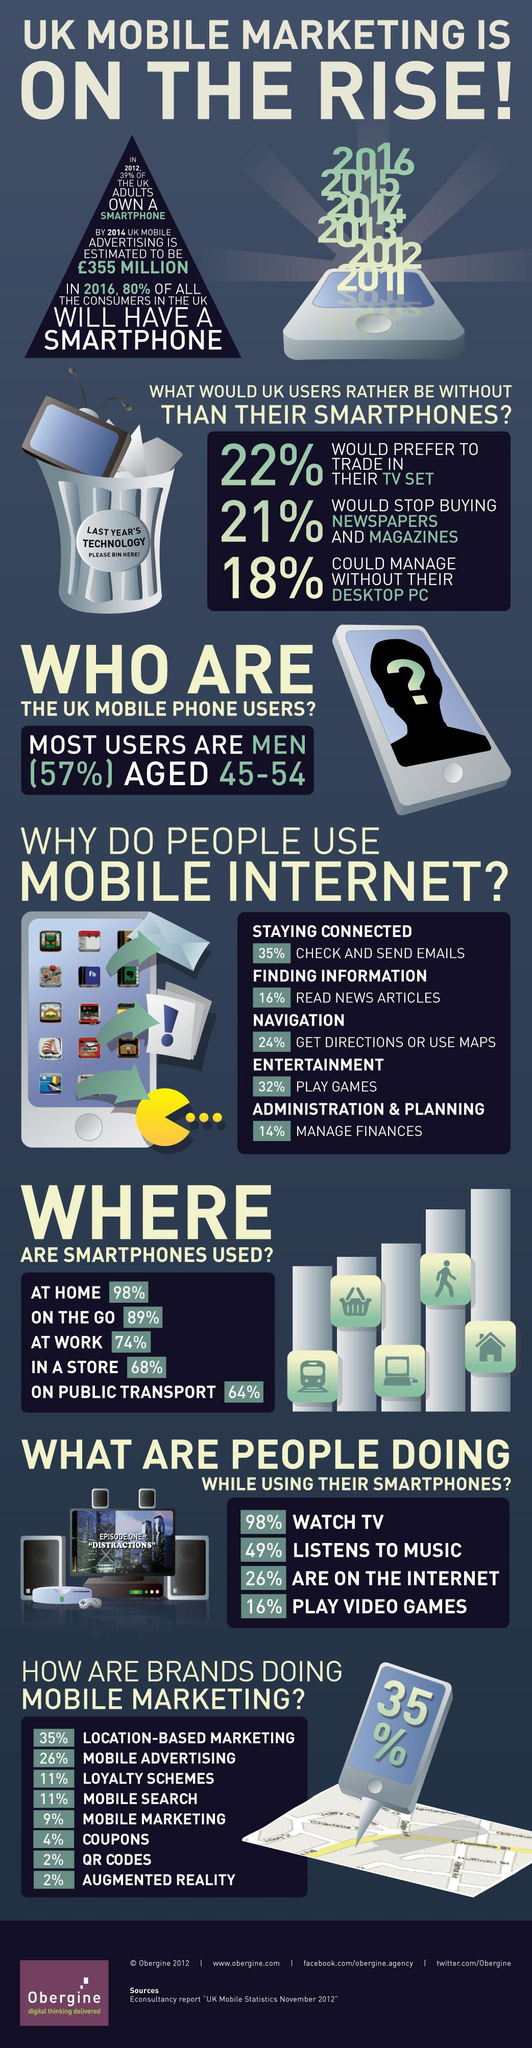Identify some key points in this picture. The second most common use of mobile internet is playing games. The smartphone is primarily used outside of the home, specifically when one is on the go. Mobile advertising is the second most commonly used method for mobile marketing among brands. According to a recent survey, 16% of people play video games on their smartphones. The vast majority of individuals utilize their mobile internet primarily for checking and sending emails. 